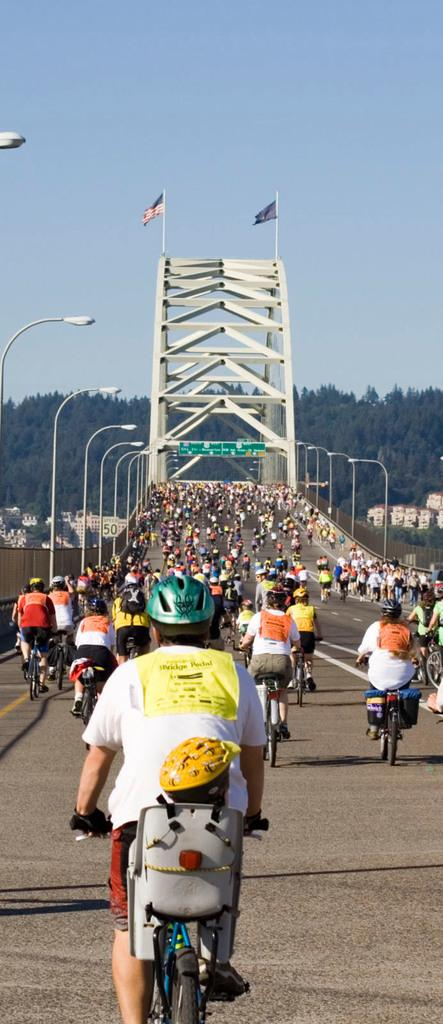How many people are in the image? There are people in the image, but the exact number is not specified. What are the people doing in the image? The people are sitting on bicycles in the image. What safety precaution are the people taking? The people are wearing helmets in the image. What can be seen in the background of the image? In the background of the image, there are flags, trees, street lights, and the sky. What type of apparel are the ants wearing in the image? There are no ants present in the image, and therefore no apparel can be observed on them. 